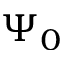<formula> <loc_0><loc_0><loc_500><loc_500>\Psi _ { 0 }</formula> 